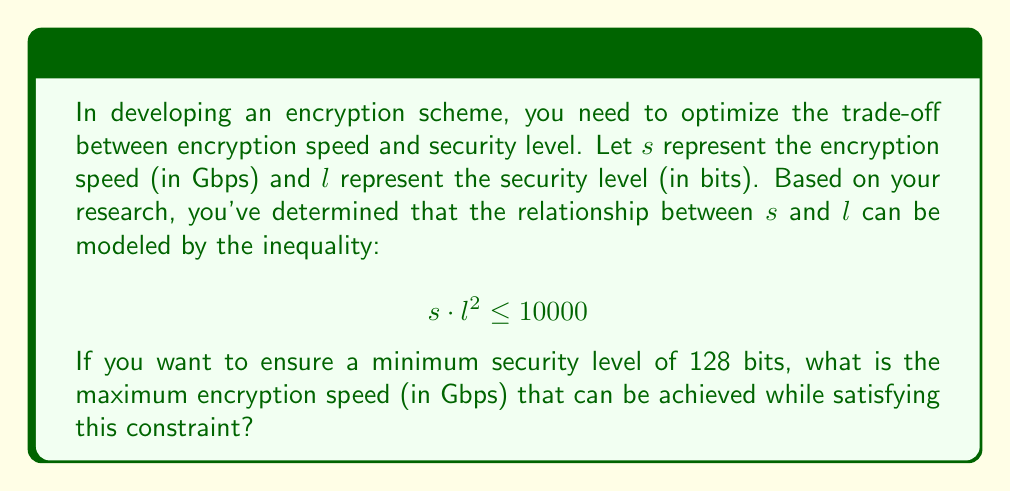Could you help me with this problem? To solve this problem, we'll follow these steps:

1) We start with the given inequality:
   $$s \cdot l^2 \leq 10000$$

2) We're told that the minimum security level should be 128 bits. This means:
   $$l = 128$$

3) Substituting this into our inequality:
   $$s \cdot 128^2 \leq 10000$$

4) Simplify:
   $$s \cdot 16384 \leq 10000$$

5) Isolate $s$:
   $$s \leq \frac{10000}{16384}$$

6) Calculate the result:
   $$s \leq 0.610351562...$$

7) Since we're looking for the maximum speed, we take the upper bound of this inequality.

8) Rounding to 3 decimal places for practical purposes:
   $$s \approx 0.610 \text{ Gbps}$$
Answer: 0.610 Gbps 